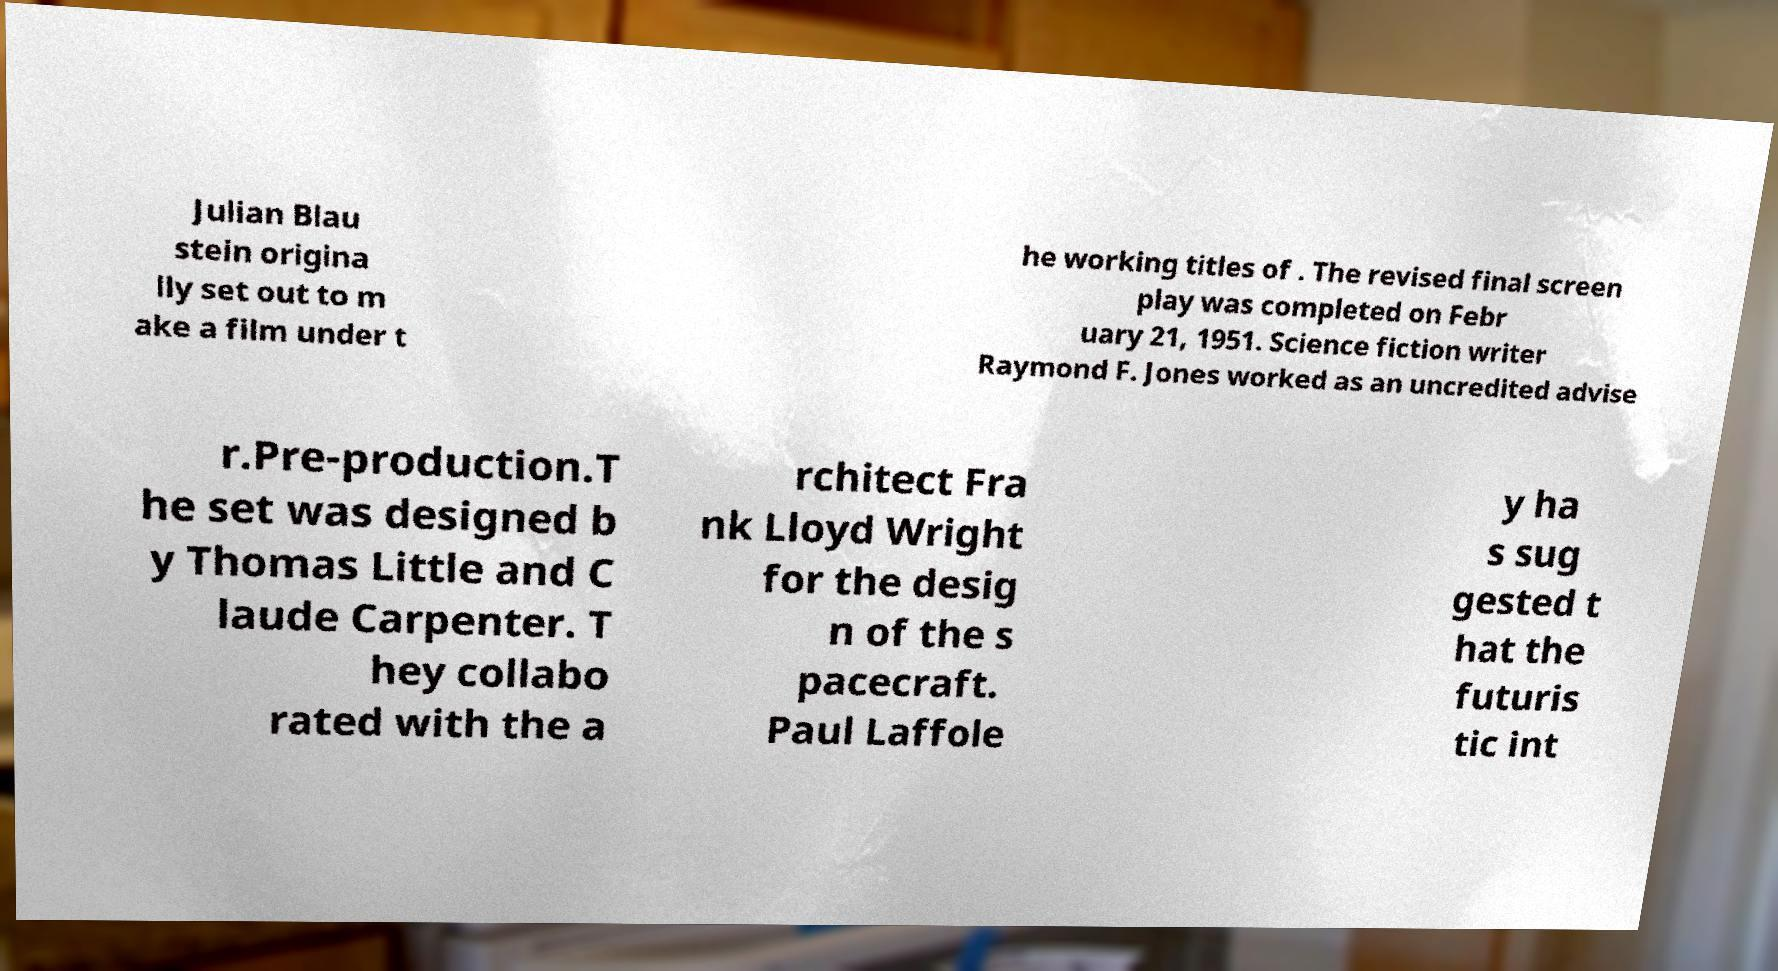Can you accurately transcribe the text from the provided image for me? Julian Blau stein origina lly set out to m ake a film under t he working titles of . The revised final screen play was completed on Febr uary 21, 1951. Science fiction writer Raymond F. Jones worked as an uncredited advise r.Pre-production.T he set was designed b y Thomas Little and C laude Carpenter. T hey collabo rated with the a rchitect Fra nk Lloyd Wright for the desig n of the s pacecraft. Paul Laffole y ha s sug gested t hat the futuris tic int 